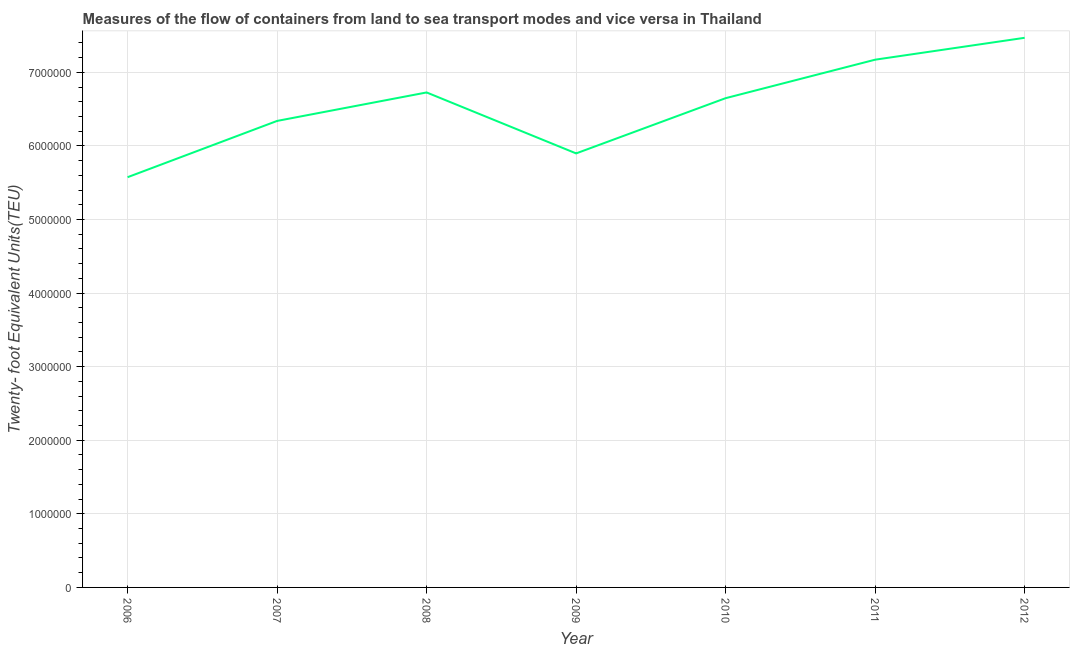What is the container port traffic in 2008?
Make the answer very short. 6.73e+06. Across all years, what is the maximum container port traffic?
Keep it short and to the point. 7.47e+06. Across all years, what is the minimum container port traffic?
Make the answer very short. 5.57e+06. In which year was the container port traffic maximum?
Provide a succinct answer. 2012. In which year was the container port traffic minimum?
Provide a succinct answer. 2006. What is the sum of the container port traffic?
Make the answer very short. 4.58e+07. What is the difference between the container port traffic in 2010 and 2011?
Keep it short and to the point. -5.23e+05. What is the average container port traffic per year?
Ensure brevity in your answer.  6.55e+06. What is the median container port traffic?
Offer a very short reply. 6.65e+06. What is the ratio of the container port traffic in 2011 to that in 2012?
Provide a succinct answer. 0.96. Is the difference between the container port traffic in 2006 and 2008 greater than the difference between any two years?
Your answer should be very brief. No. What is the difference between the highest and the second highest container port traffic?
Offer a terse response. 2.98e+05. What is the difference between the highest and the lowest container port traffic?
Keep it short and to the point. 1.89e+06. How many lines are there?
Ensure brevity in your answer.  1. Are the values on the major ticks of Y-axis written in scientific E-notation?
Provide a succinct answer. No. What is the title of the graph?
Keep it short and to the point. Measures of the flow of containers from land to sea transport modes and vice versa in Thailand. What is the label or title of the Y-axis?
Offer a terse response. Twenty- foot Equivalent Units(TEU). What is the Twenty- foot Equivalent Units(TEU) of 2006?
Keep it short and to the point. 5.57e+06. What is the Twenty- foot Equivalent Units(TEU) in 2007?
Offer a very short reply. 6.34e+06. What is the Twenty- foot Equivalent Units(TEU) of 2008?
Make the answer very short. 6.73e+06. What is the Twenty- foot Equivalent Units(TEU) in 2009?
Your response must be concise. 5.90e+06. What is the Twenty- foot Equivalent Units(TEU) in 2010?
Ensure brevity in your answer.  6.65e+06. What is the Twenty- foot Equivalent Units(TEU) of 2011?
Offer a very short reply. 7.17e+06. What is the Twenty- foot Equivalent Units(TEU) in 2012?
Offer a terse response. 7.47e+06. What is the difference between the Twenty- foot Equivalent Units(TEU) in 2006 and 2007?
Keep it short and to the point. -7.65e+05. What is the difference between the Twenty- foot Equivalent Units(TEU) in 2006 and 2008?
Make the answer very short. -1.15e+06. What is the difference between the Twenty- foot Equivalent Units(TEU) in 2006 and 2009?
Make the answer very short. -3.23e+05. What is the difference between the Twenty- foot Equivalent Units(TEU) in 2006 and 2010?
Make the answer very short. -1.07e+06. What is the difference between the Twenty- foot Equivalent Units(TEU) in 2006 and 2011?
Offer a terse response. -1.60e+06. What is the difference between the Twenty- foot Equivalent Units(TEU) in 2006 and 2012?
Your answer should be compact. -1.89e+06. What is the difference between the Twenty- foot Equivalent Units(TEU) in 2007 and 2008?
Your answer should be compact. -3.87e+05. What is the difference between the Twenty- foot Equivalent Units(TEU) in 2007 and 2009?
Give a very brief answer. 4.41e+05. What is the difference between the Twenty- foot Equivalent Units(TEU) in 2007 and 2010?
Provide a succinct answer. -3.09e+05. What is the difference between the Twenty- foot Equivalent Units(TEU) in 2007 and 2011?
Provide a succinct answer. -8.32e+05. What is the difference between the Twenty- foot Equivalent Units(TEU) in 2007 and 2012?
Make the answer very short. -1.13e+06. What is the difference between the Twenty- foot Equivalent Units(TEU) in 2008 and 2009?
Your response must be concise. 8.28e+05. What is the difference between the Twenty- foot Equivalent Units(TEU) in 2008 and 2010?
Provide a short and direct response. 7.77e+04. What is the difference between the Twenty- foot Equivalent Units(TEU) in 2008 and 2011?
Give a very brief answer. -4.45e+05. What is the difference between the Twenty- foot Equivalent Units(TEU) in 2008 and 2012?
Make the answer very short. -7.43e+05. What is the difference between the Twenty- foot Equivalent Units(TEU) in 2009 and 2010?
Your answer should be very brief. -7.51e+05. What is the difference between the Twenty- foot Equivalent Units(TEU) in 2009 and 2011?
Your response must be concise. -1.27e+06. What is the difference between the Twenty- foot Equivalent Units(TEU) in 2009 and 2012?
Provide a succinct answer. -1.57e+06. What is the difference between the Twenty- foot Equivalent Units(TEU) in 2010 and 2011?
Give a very brief answer. -5.23e+05. What is the difference between the Twenty- foot Equivalent Units(TEU) in 2010 and 2012?
Provide a succinct answer. -8.20e+05. What is the difference between the Twenty- foot Equivalent Units(TEU) in 2011 and 2012?
Ensure brevity in your answer.  -2.98e+05. What is the ratio of the Twenty- foot Equivalent Units(TEU) in 2006 to that in 2007?
Provide a succinct answer. 0.88. What is the ratio of the Twenty- foot Equivalent Units(TEU) in 2006 to that in 2008?
Offer a very short reply. 0.83. What is the ratio of the Twenty- foot Equivalent Units(TEU) in 2006 to that in 2009?
Give a very brief answer. 0.94. What is the ratio of the Twenty- foot Equivalent Units(TEU) in 2006 to that in 2010?
Offer a very short reply. 0.84. What is the ratio of the Twenty- foot Equivalent Units(TEU) in 2006 to that in 2011?
Your answer should be compact. 0.78. What is the ratio of the Twenty- foot Equivalent Units(TEU) in 2006 to that in 2012?
Your answer should be very brief. 0.75. What is the ratio of the Twenty- foot Equivalent Units(TEU) in 2007 to that in 2008?
Offer a very short reply. 0.94. What is the ratio of the Twenty- foot Equivalent Units(TEU) in 2007 to that in 2009?
Your answer should be very brief. 1.07. What is the ratio of the Twenty- foot Equivalent Units(TEU) in 2007 to that in 2010?
Offer a very short reply. 0.95. What is the ratio of the Twenty- foot Equivalent Units(TEU) in 2007 to that in 2011?
Your answer should be very brief. 0.88. What is the ratio of the Twenty- foot Equivalent Units(TEU) in 2007 to that in 2012?
Offer a terse response. 0.85. What is the ratio of the Twenty- foot Equivalent Units(TEU) in 2008 to that in 2009?
Your answer should be very brief. 1.14. What is the ratio of the Twenty- foot Equivalent Units(TEU) in 2008 to that in 2011?
Your answer should be very brief. 0.94. What is the ratio of the Twenty- foot Equivalent Units(TEU) in 2008 to that in 2012?
Provide a short and direct response. 0.9. What is the ratio of the Twenty- foot Equivalent Units(TEU) in 2009 to that in 2010?
Your answer should be compact. 0.89. What is the ratio of the Twenty- foot Equivalent Units(TEU) in 2009 to that in 2011?
Your response must be concise. 0.82. What is the ratio of the Twenty- foot Equivalent Units(TEU) in 2009 to that in 2012?
Provide a short and direct response. 0.79. What is the ratio of the Twenty- foot Equivalent Units(TEU) in 2010 to that in 2011?
Provide a succinct answer. 0.93. What is the ratio of the Twenty- foot Equivalent Units(TEU) in 2010 to that in 2012?
Provide a succinct answer. 0.89. 